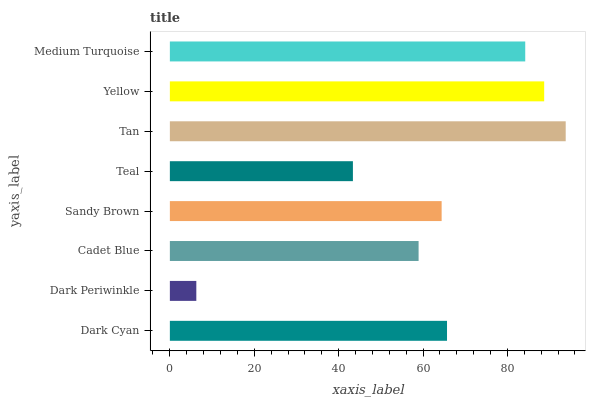Is Dark Periwinkle the minimum?
Answer yes or no. Yes. Is Tan the maximum?
Answer yes or no. Yes. Is Cadet Blue the minimum?
Answer yes or no. No. Is Cadet Blue the maximum?
Answer yes or no. No. Is Cadet Blue greater than Dark Periwinkle?
Answer yes or no. Yes. Is Dark Periwinkle less than Cadet Blue?
Answer yes or no. Yes. Is Dark Periwinkle greater than Cadet Blue?
Answer yes or no. No. Is Cadet Blue less than Dark Periwinkle?
Answer yes or no. No. Is Dark Cyan the high median?
Answer yes or no. Yes. Is Sandy Brown the low median?
Answer yes or no. Yes. Is Yellow the high median?
Answer yes or no. No. Is Cadet Blue the low median?
Answer yes or no. No. 